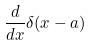<formula> <loc_0><loc_0><loc_500><loc_500>\frac { d } { d x } \delta ( x - a )</formula> 